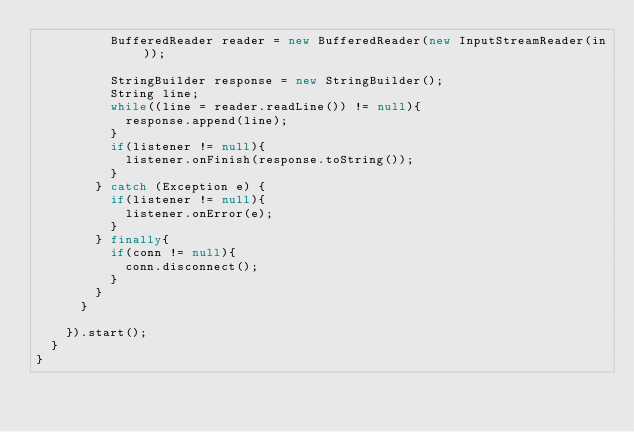Convert code to text. <code><loc_0><loc_0><loc_500><loc_500><_Java_>					BufferedReader reader = new BufferedReader(new InputStreamReader(in));
					
					StringBuilder response = new StringBuilder();
					String line;
					while((line = reader.readLine()) != null){
						response.append(line);	
					}
					if(listener != null){
						listener.onFinish(response.toString());
					}
				} catch (Exception e) {
					if(listener != null){
						listener.onError(e);
					}
				} finally{
					if(conn != null){
						conn.disconnect();
					}
				}
			}
			
		}).start();
	}
}
</code> 